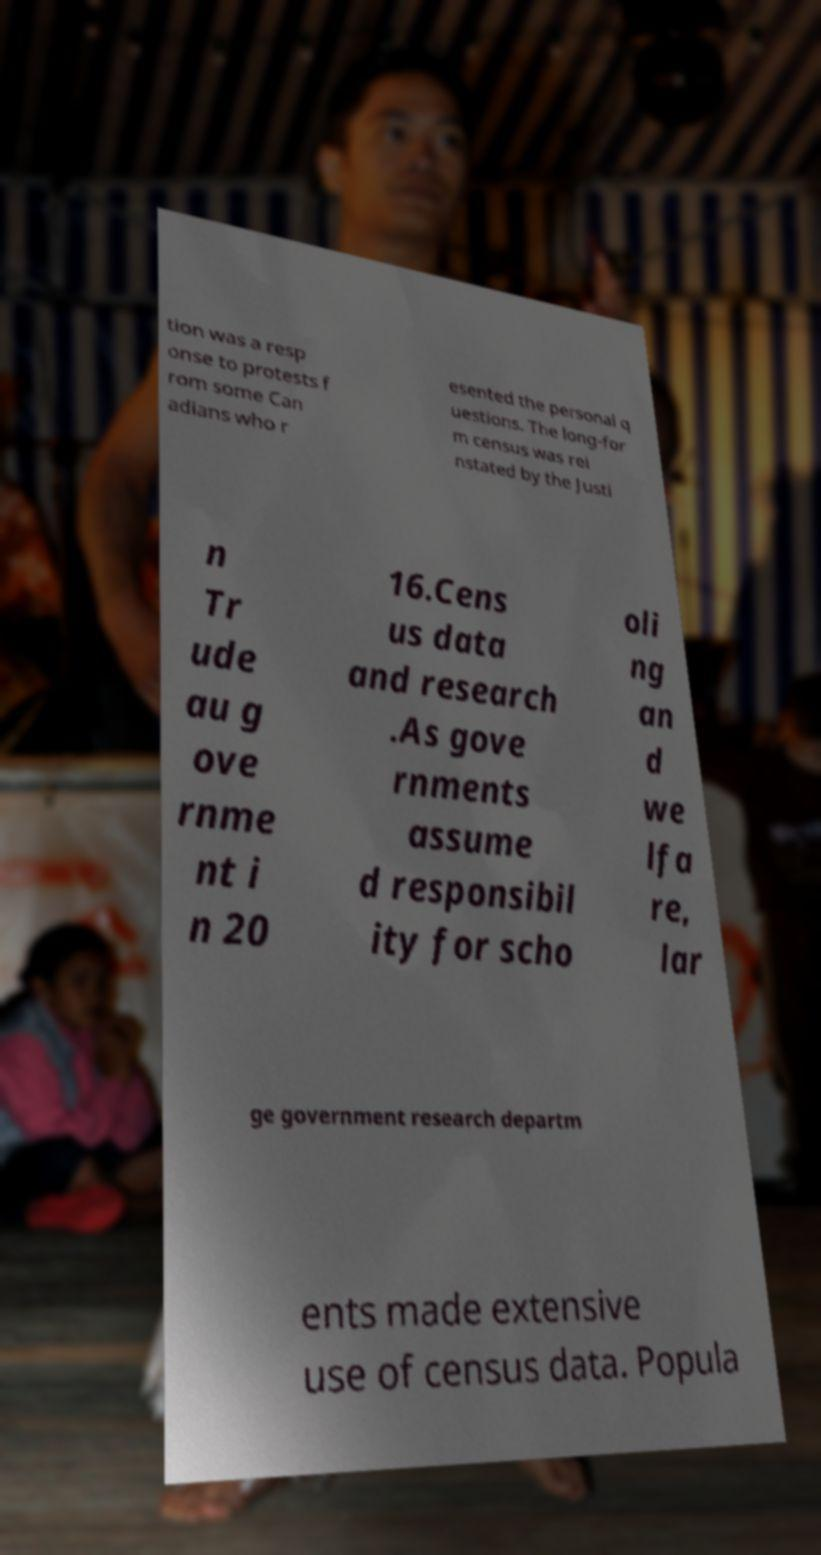Could you extract and type out the text from this image? tion was a resp onse to protests f rom some Can adians who r esented the personal q uestions. The long-for m census was rei nstated by the Justi n Tr ude au g ove rnme nt i n 20 16.Cens us data and research .As gove rnments assume d responsibil ity for scho oli ng an d we lfa re, lar ge government research departm ents made extensive use of census data. Popula 